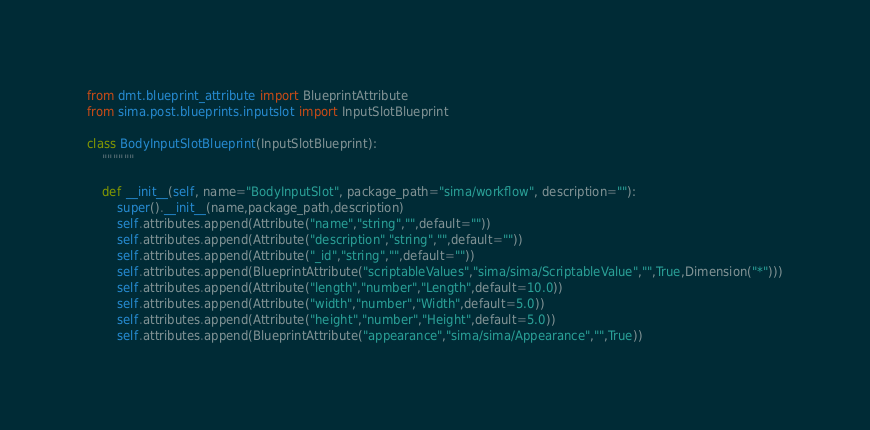Convert code to text. <code><loc_0><loc_0><loc_500><loc_500><_Python_>from dmt.blueprint_attribute import BlueprintAttribute
from sima.post.blueprints.inputslot import InputSlotBlueprint

class BodyInputSlotBlueprint(InputSlotBlueprint):
    """"""

    def __init__(self, name="BodyInputSlot", package_path="sima/workflow", description=""):
        super().__init__(name,package_path,description)
        self.attributes.append(Attribute("name","string","",default=""))
        self.attributes.append(Attribute("description","string","",default=""))
        self.attributes.append(Attribute("_id","string","",default=""))
        self.attributes.append(BlueprintAttribute("scriptableValues","sima/sima/ScriptableValue","",True,Dimension("*")))
        self.attributes.append(Attribute("length","number","Length",default=10.0))
        self.attributes.append(Attribute("width","number","Width",default=5.0))
        self.attributes.append(Attribute("height","number","Height",default=5.0))
        self.attributes.append(BlueprintAttribute("appearance","sima/sima/Appearance","",True))</code> 